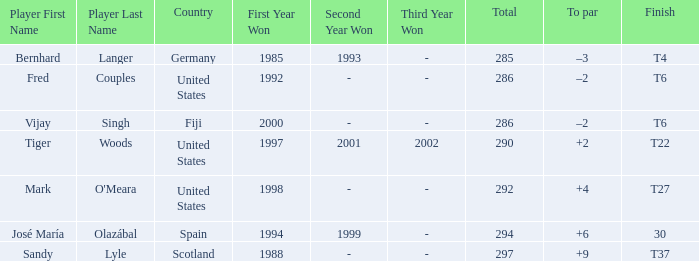Which country has a finish of t22? United States. 